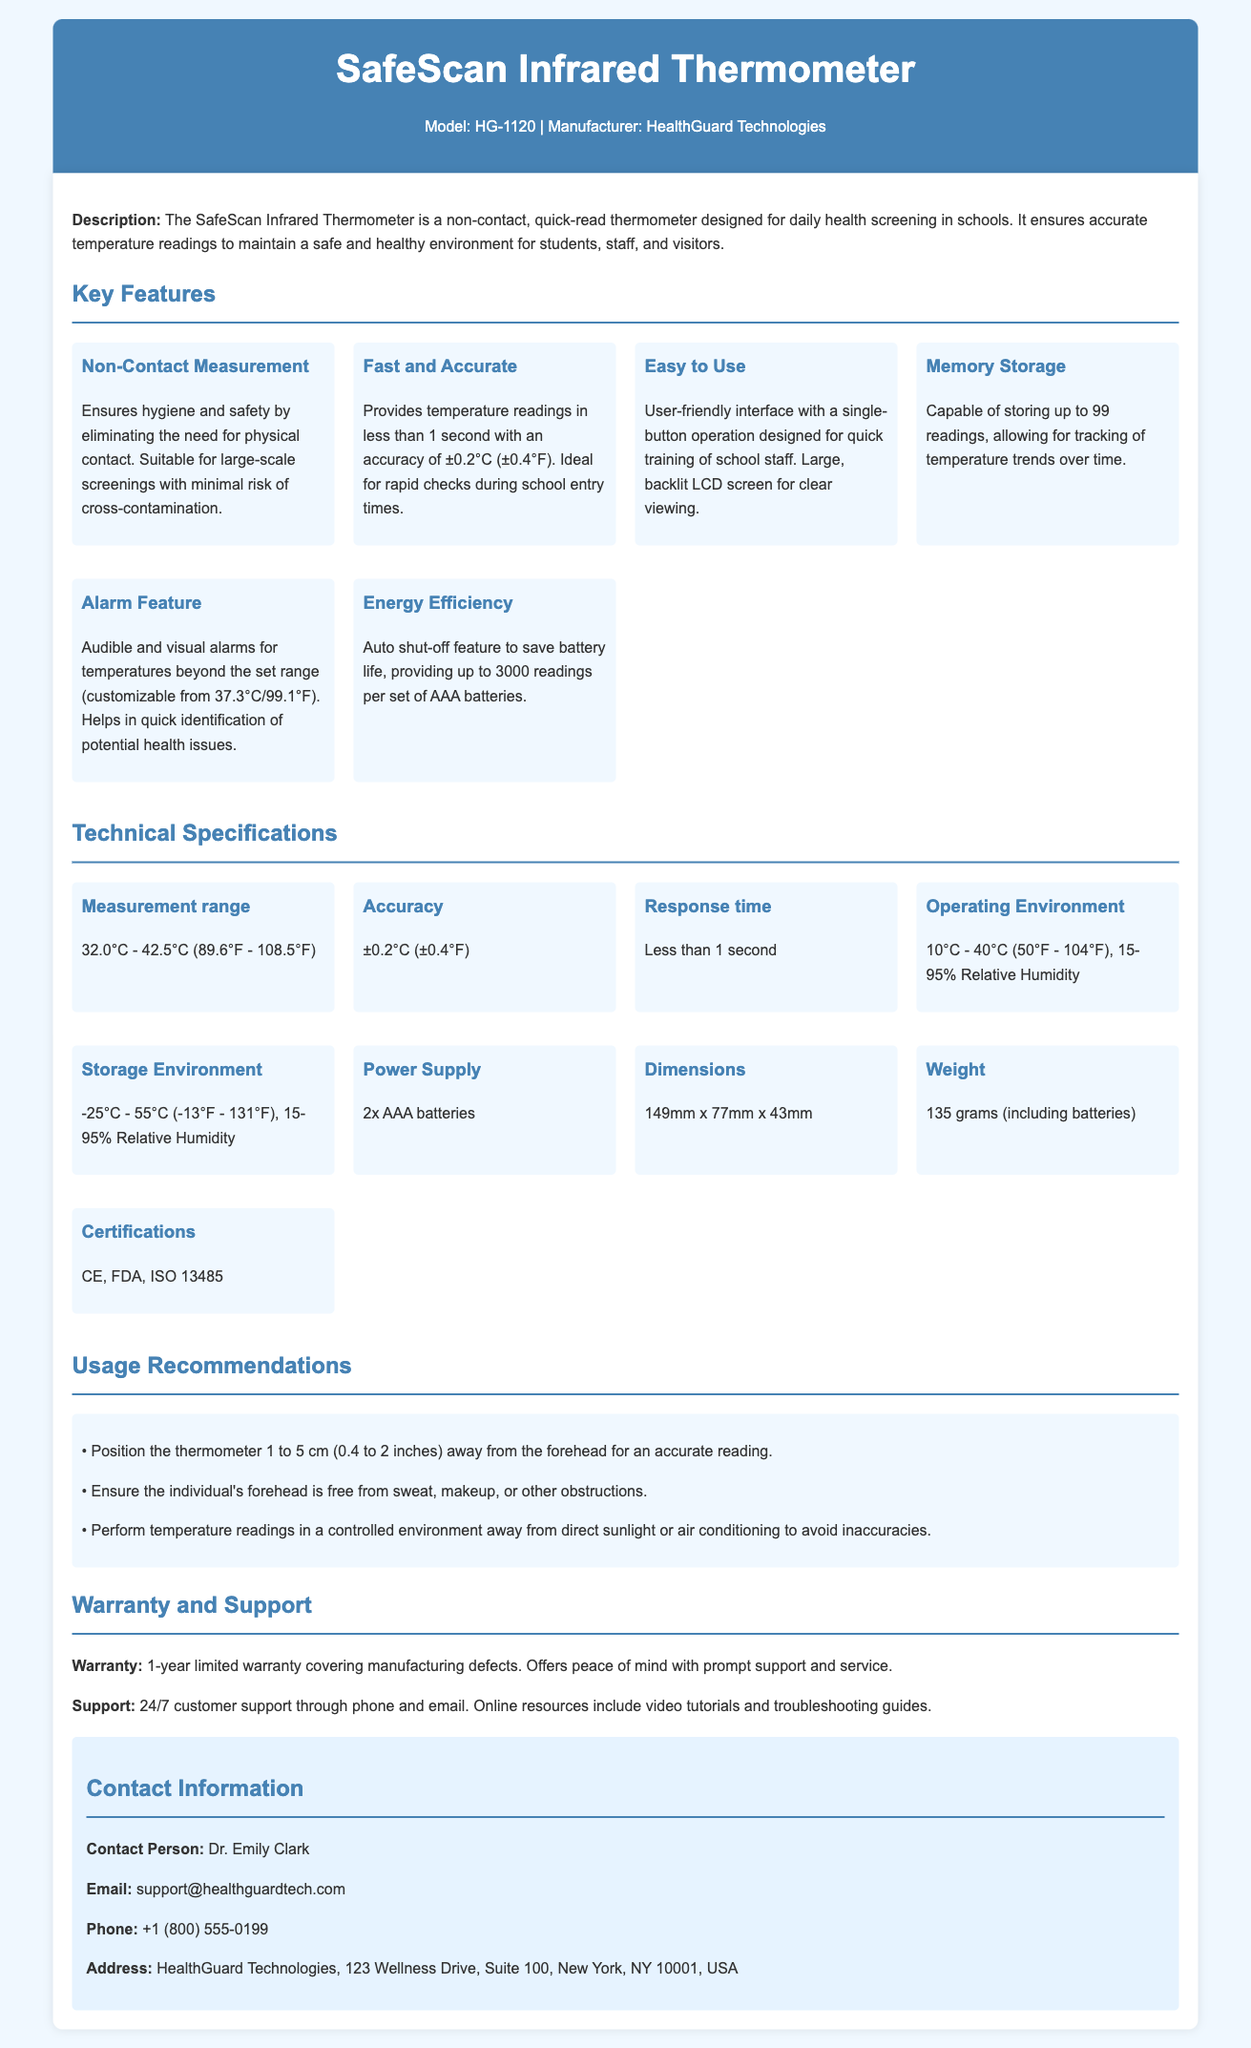What is the model of the thermometer? The model of the thermometer is specified in the header section of the document.
Answer: HG-1120 What is the measurement range of the thermometer? The measurement range is listed in the technical specifications section of the document.
Answer: 32.0°C - 42.5°C (89.6°F - 108.5°F) What is the accuracy of the thermometer? The accuracy is found in the technical specifications and indicates how precise the readings are.
Answer: ±0.2°C (±0.4°F) How long is the warranty for the product? The warranty information is in the warranty and support section, indicating the duration for which defects are covered.
Answer: 1-year limited warranty What feature helps in quick identification of potential health issues? This feature is found in the key features section and indicates how it alerts users to abnormal readings.
Answer: Alarm Feature How many readings can the thermometer store? The memory storage capacity is mentioned under the key features section.
Answer: 99 readings What is the battery supply required for the thermometer? The power supply information is located in the technical specifications section.
Answer: 2x AAA batteries What type of alarms does the thermometer have? This information is located under the Alarm Feature in the key features section of the document.
Answer: Audible and visual alarms What is the recommended distance for taking a measurement? Usage recommendations provide guidance on how to properly use the thermometer for accuracy.
Answer: 1 to 5 cm (0.4 to 2 inches) 